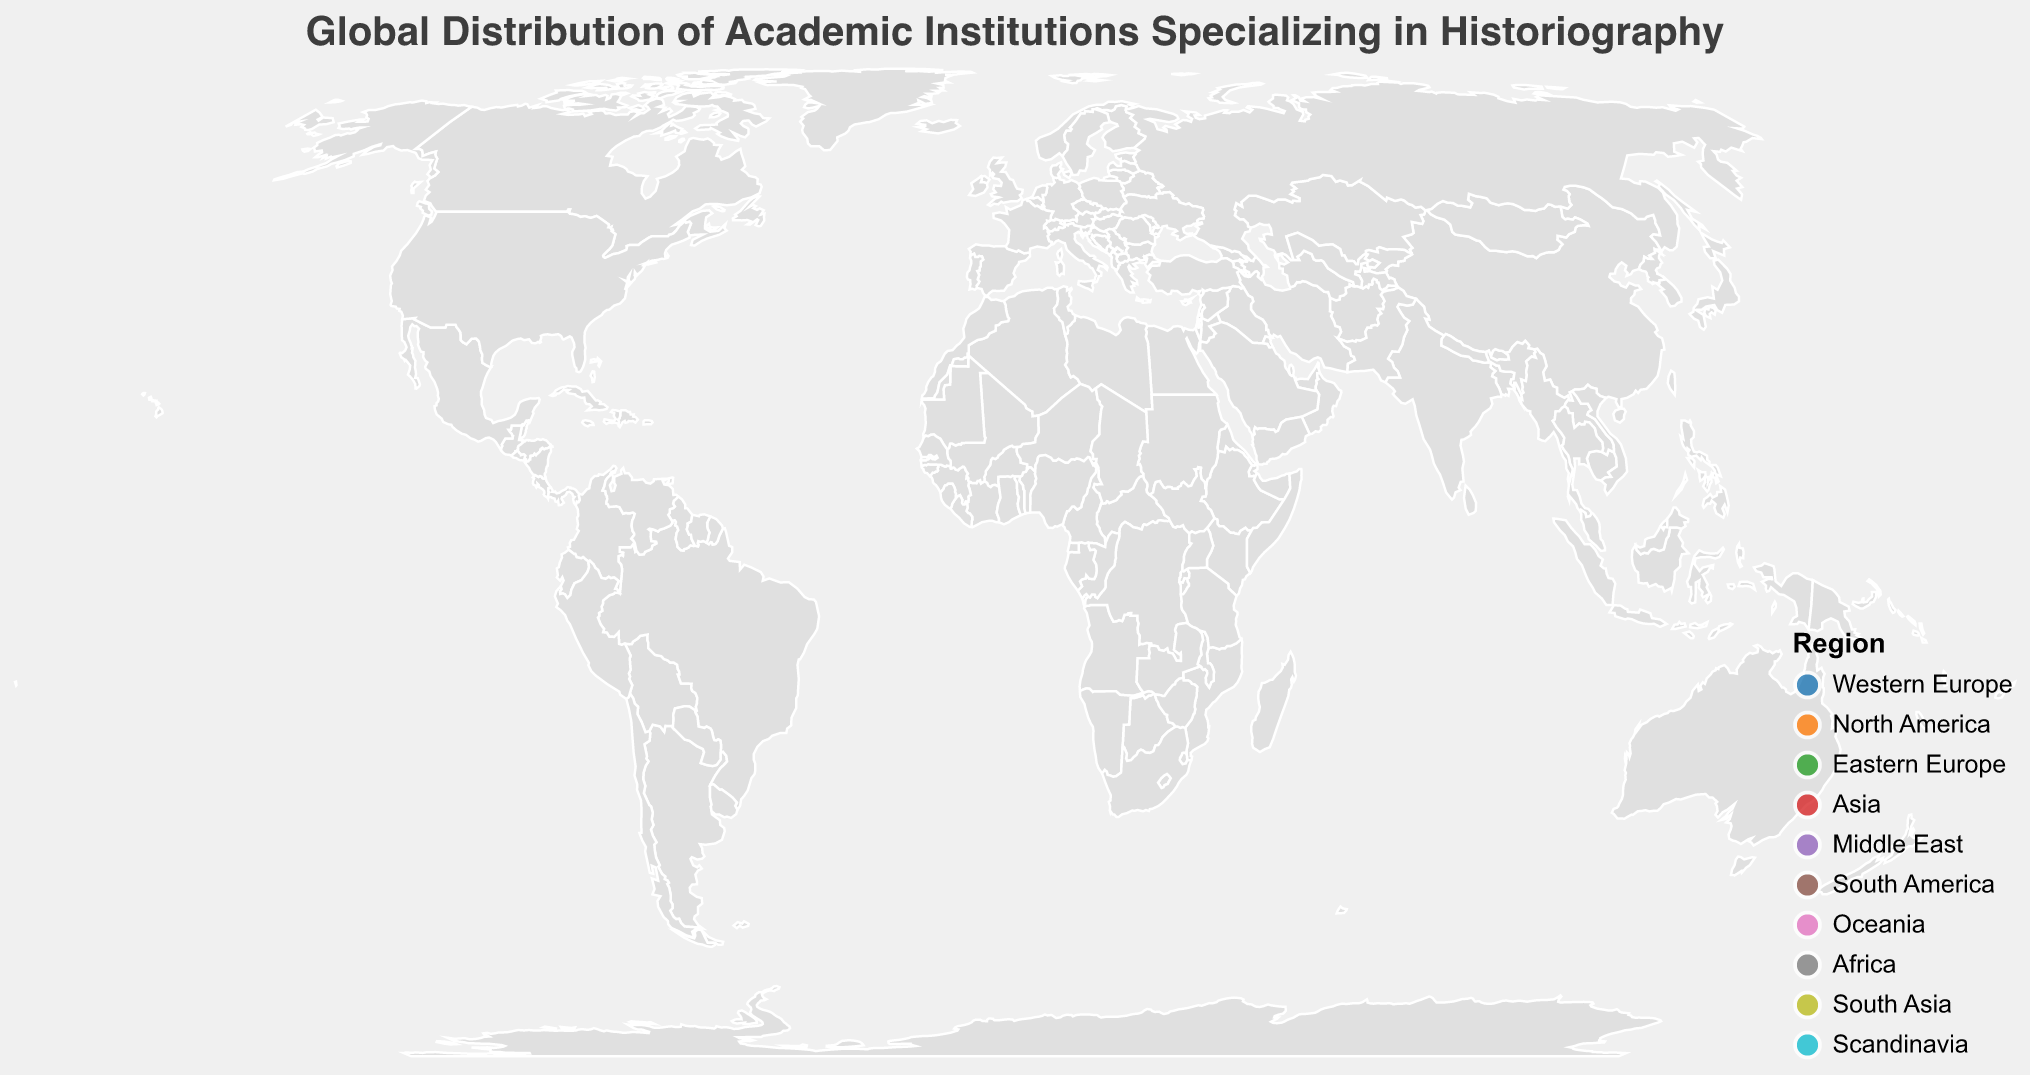Which region has the highest concentration of academic institutions specializing in historiography according to the plot? By observing the number of circles representing institutions in each region, it's evident that Western Europe has the highest concentration.
Answer: Western Europe Which institution has the highest specialization score? By examining the tooltip for each academic institution, we can see that Harvard University in the United States has the highest specialization score of 98.
Answer: Harvard University What is the average specialization score of institutions in Western Europe? The institutions in Western Europe are University of Oxford (95), Free University of Berlin (88), and École des Hautes Études en Sciences Sociales (92). Their average specialization score is (95 + 88 + 92) / 3 = 91.67.
Answer: 91.67 Compare the specialization scores of the University of Tokyo and Peking University. Which one is higher? By looking at the scores in the tooltip, University of Tokyo (82) has a higher specialization score than Peking University (79).
Answer: University of Tokyo Which region has the least number of institutions on the plot? By counting the number of circles, each representing an institution, we see that South Asia, Scandinavia, South America, and Africa each have one institution, indicating they have the least number.
Answer: South Asia, Scandinavia, South America, Africa What is the total specialization score of all institutions in North America? The institutions in North America are Harvard University (98) and University of Toronto (85). Their total specialization score is 98 + 85 = 183.
Answer: 183 How does the specialization score of Hebrew University of Jerusalem compare to École des Hautes Études en Sciences Sociales? Reviewing the scores in the tooltip, Hebrew University of Jerusalem has a score of 87, while École des Hautes Études en Sciences Sociales has a score of 92. École des Hautes Études en Sciences Sociales has a higher score.
Answer: École des Hautes Études en Sciences Sociales Which institution in Eastern Europe has a higher specialization score, Moscow State University or Jagiellonian University? The scores shown in the tooltip indicate that Moscow State University has a score of 80, while Jagiellonian University has a score of 78. Therefore, Moscow State University has a higher score.
Answer: Moscow State University What is the range of specialization scores across all regions in the plot? By identifying the highest and lowest scores in the tooltip, the maximum specialization score is 98 (Harvard University) and the minimum score is 72 (University of Cape Town). The range is 98 - 72 = 26.
Answer: 26 